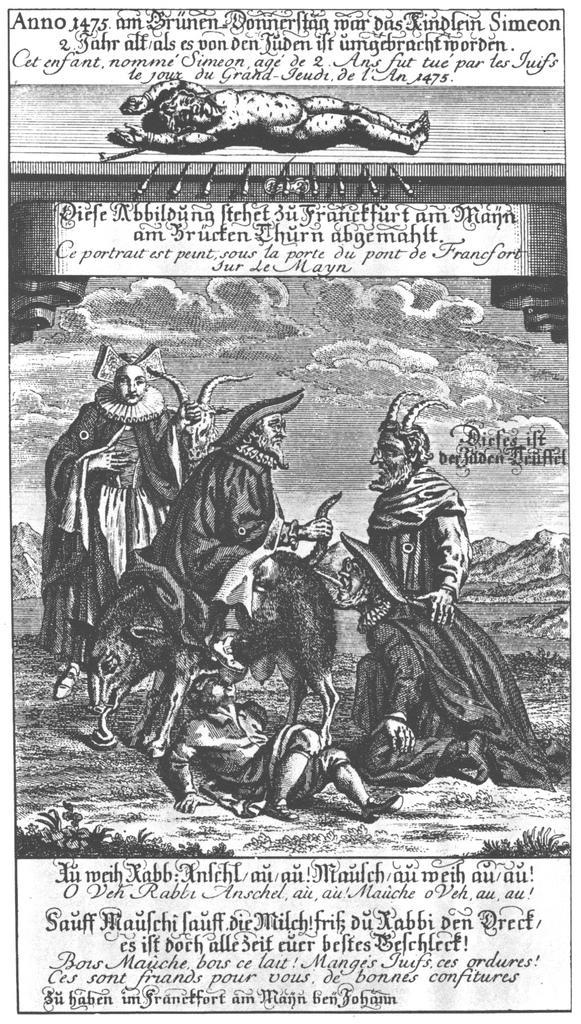Please provide a concise description of this image. In this picture there are few persons and there is something written above and below it. 